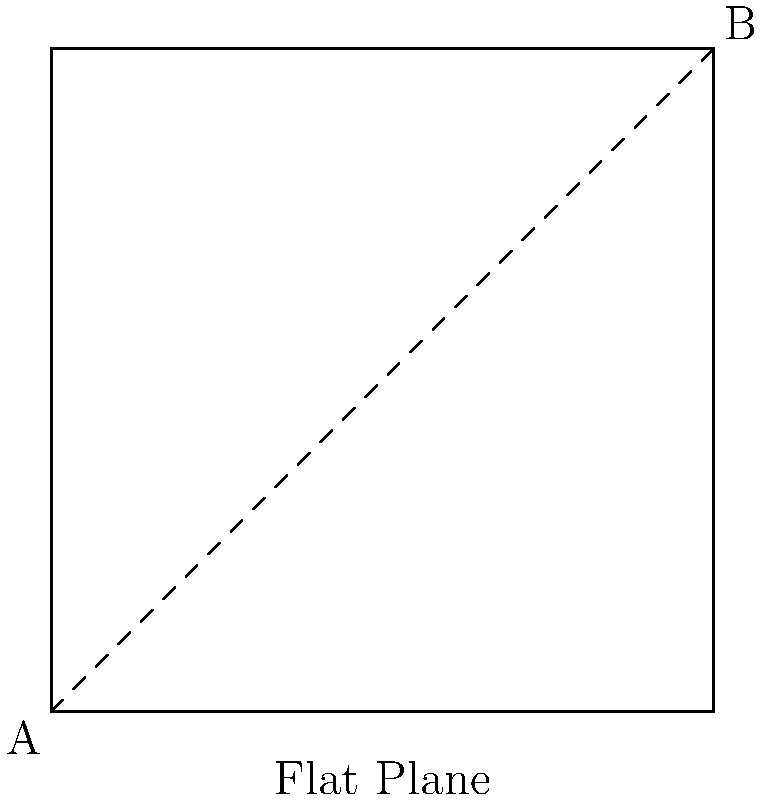Compare the shortest path between two points A and B on a flat plane versus on a curved surface (like a sphere). Which path is shorter, and why? To understand the difference between the shortest paths on a flat plane versus a curved surface, let's break it down step-by-step:

1. Flat Plane:
   - On a flat plane, the shortest path between two points is always a straight line.
   - This is based on Euclidean geometry, where the shortest distance between two points is a straight line.
   - The distance is calculated using the Pythagorean theorem: $d = \sqrt{(x_2-x_1)^2 + (y_2-y_1)^2}$

2. Curved Surface (Sphere):
   - On a curved surface like a sphere, the shortest path between two points is called a geodesic.
   - For a sphere, the geodesic is a great circle, which is the intersection of the sphere with a plane passing through the center of the sphere and both points.
   - This path appears curved when projected onto a flat surface but is actually the shortest path on the sphere's surface.

3. Comparison:
   - The straight-line path on the flat plane appears shorter when viewed from above.
   - However, the geodesic on the curved surface follows the curvature of the surface, which can actually be a shorter distance when measured along the surface.
   - This is because the geodesic "cuts through" the curvature, while a path that looks straight from above would actually be longer if it were to follow the surface contours.

4. Real-world application:
   - This concept is important in navigation, especially for long-distance flights or shipping routes.
   - Great circle routes are often used for these long-distance travels as they provide the shortest path between two points on the Earth's surface.

In conclusion, the path on the curved surface (geodesic) is actually shorter when measured along the surface, even though it may appear longer when viewed from a flat perspective.
Answer: The geodesic path on the curved surface is shorter. 